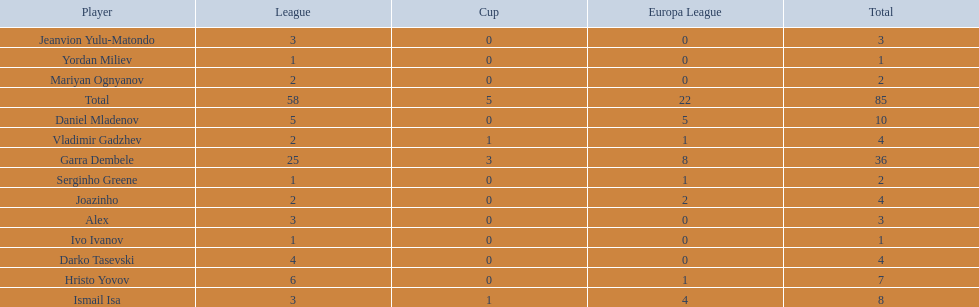How many of the players did not score any goals in the cup? 10. 